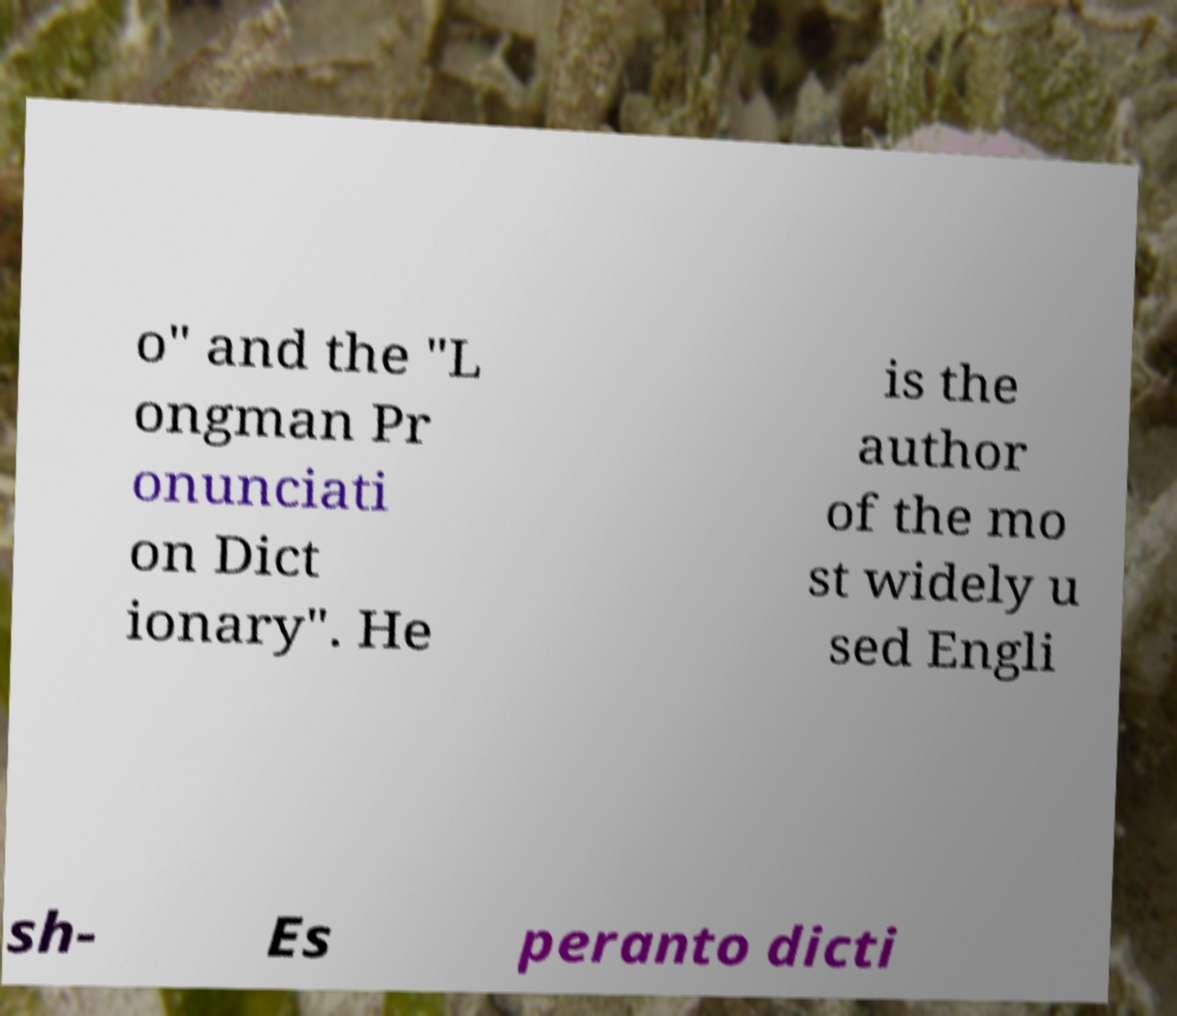Can you accurately transcribe the text from the provided image for me? o" and the "L ongman Pr onunciati on Dict ionary". He is the author of the mo st widely u sed Engli sh- Es peranto dicti 